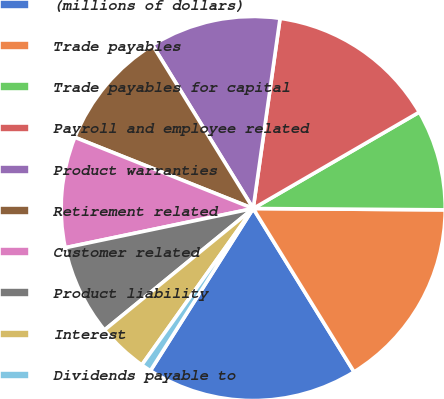<chart> <loc_0><loc_0><loc_500><loc_500><pie_chart><fcel>(millions of dollars)<fcel>Trade payables<fcel>Trade payables for capital<fcel>Payroll and employee related<fcel>Product warranties<fcel>Retirement related<fcel>Customer related<fcel>Product liability<fcel>Interest<fcel>Dividends payable to<nl><fcel>17.79%<fcel>16.09%<fcel>8.48%<fcel>14.4%<fcel>11.02%<fcel>10.17%<fcel>9.32%<fcel>7.63%<fcel>4.25%<fcel>0.86%<nl></chart> 